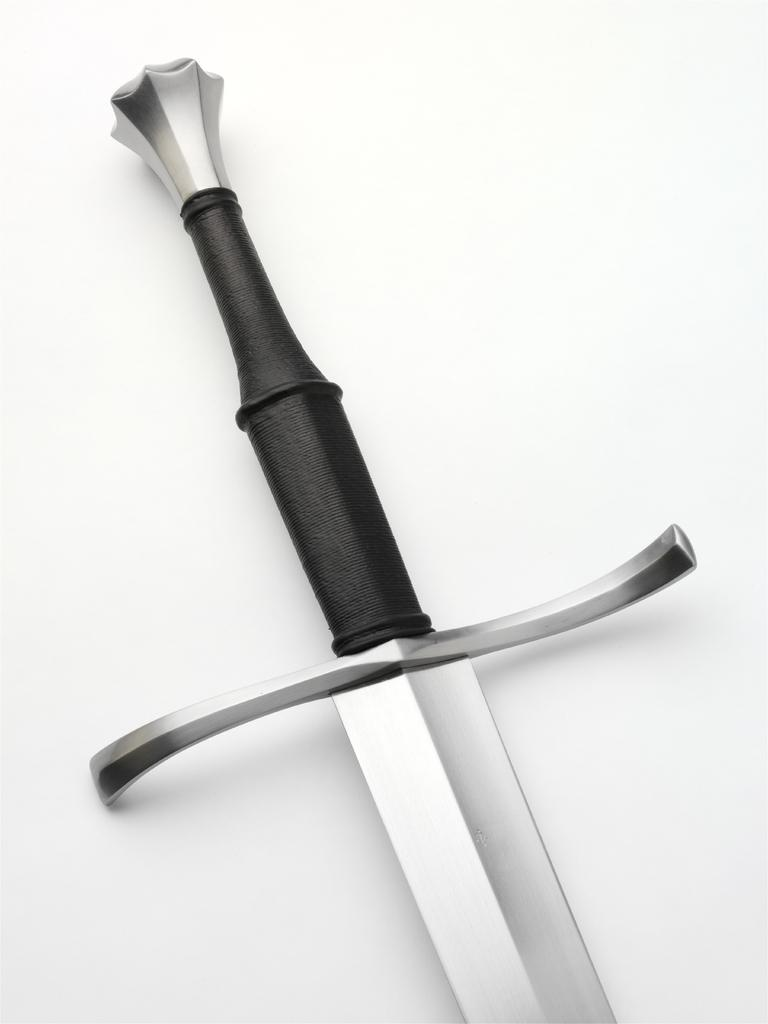What is the main object in the image? There is a sword in the image. What is the color of the surface the sword is placed on? The sword is on a white surface. How many family members are present in the image? There is no family member present in the image; it only features a sword on a white surface. What type of grain is visible in the image? There is no grain present in the image; it only features a sword on a white surface. 